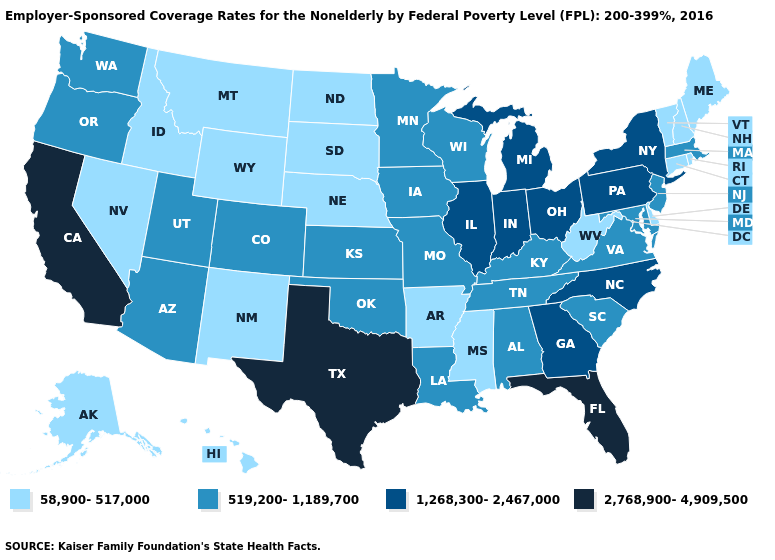Does New Jersey have the same value as Oklahoma?
Be succinct. Yes. Does Texas have the lowest value in the South?
Be succinct. No. What is the highest value in states that border Minnesota?
Keep it brief. 519,200-1,189,700. Does Massachusetts have the highest value in the USA?
Short answer required. No. What is the lowest value in states that border Michigan?
Give a very brief answer. 519,200-1,189,700. Name the states that have a value in the range 2,768,900-4,909,500?
Write a very short answer. California, Florida, Texas. Which states have the lowest value in the USA?
Answer briefly. Alaska, Arkansas, Connecticut, Delaware, Hawaii, Idaho, Maine, Mississippi, Montana, Nebraska, Nevada, New Hampshire, New Mexico, North Dakota, Rhode Island, South Dakota, Vermont, West Virginia, Wyoming. What is the highest value in the MidWest ?
Concise answer only. 1,268,300-2,467,000. Name the states that have a value in the range 58,900-517,000?
Answer briefly. Alaska, Arkansas, Connecticut, Delaware, Hawaii, Idaho, Maine, Mississippi, Montana, Nebraska, Nevada, New Hampshire, New Mexico, North Dakota, Rhode Island, South Dakota, Vermont, West Virginia, Wyoming. Is the legend a continuous bar?
Keep it brief. No. Which states have the highest value in the USA?
Quick response, please. California, Florida, Texas. Does Maryland have the lowest value in the USA?
Concise answer only. No. Does Florida have the highest value in the USA?
Quick response, please. Yes. Which states have the highest value in the USA?
Write a very short answer. California, Florida, Texas. What is the highest value in the USA?
Concise answer only. 2,768,900-4,909,500. 